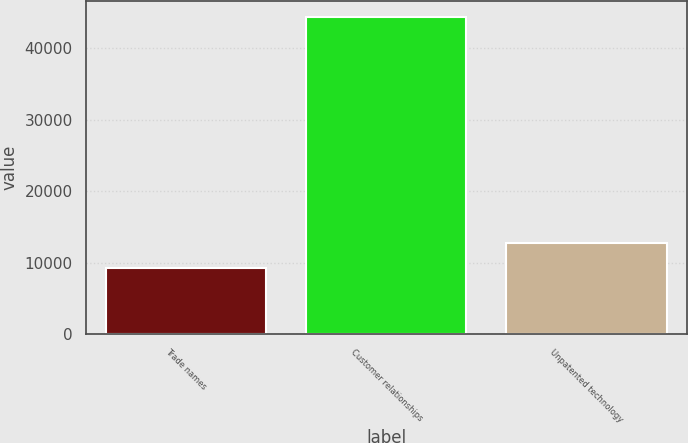Convert chart. <chart><loc_0><loc_0><loc_500><loc_500><bar_chart><fcel>Trade names<fcel>Customer relationships<fcel>Unpatented technology<nl><fcel>9247<fcel>44401<fcel>12762.4<nl></chart> 